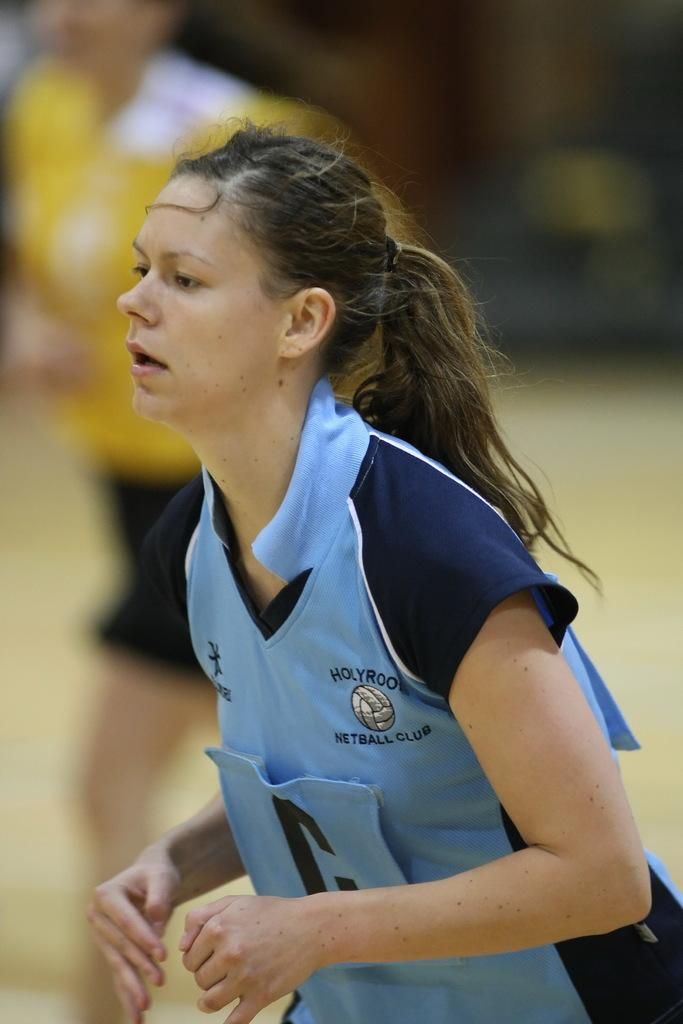<image>
Write a terse but informative summary of the picture. A girl wearing a blue jersey has the letter C on the front and a logo for Hollyroo Netball Club 